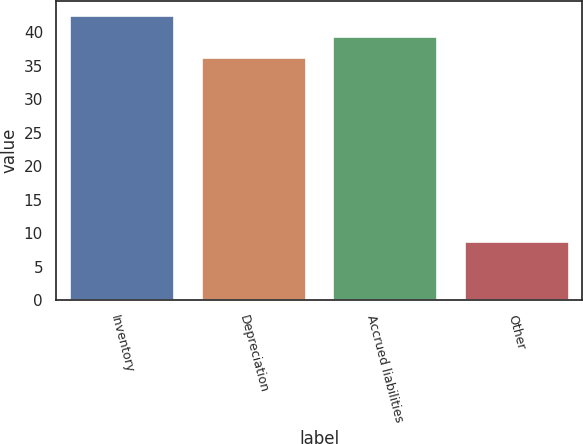<chart> <loc_0><loc_0><loc_500><loc_500><bar_chart><fcel>Inventory<fcel>Depreciation<fcel>Accrued liabilities<fcel>Other<nl><fcel>42.54<fcel>36.3<fcel>39.42<fcel>8.9<nl></chart> 